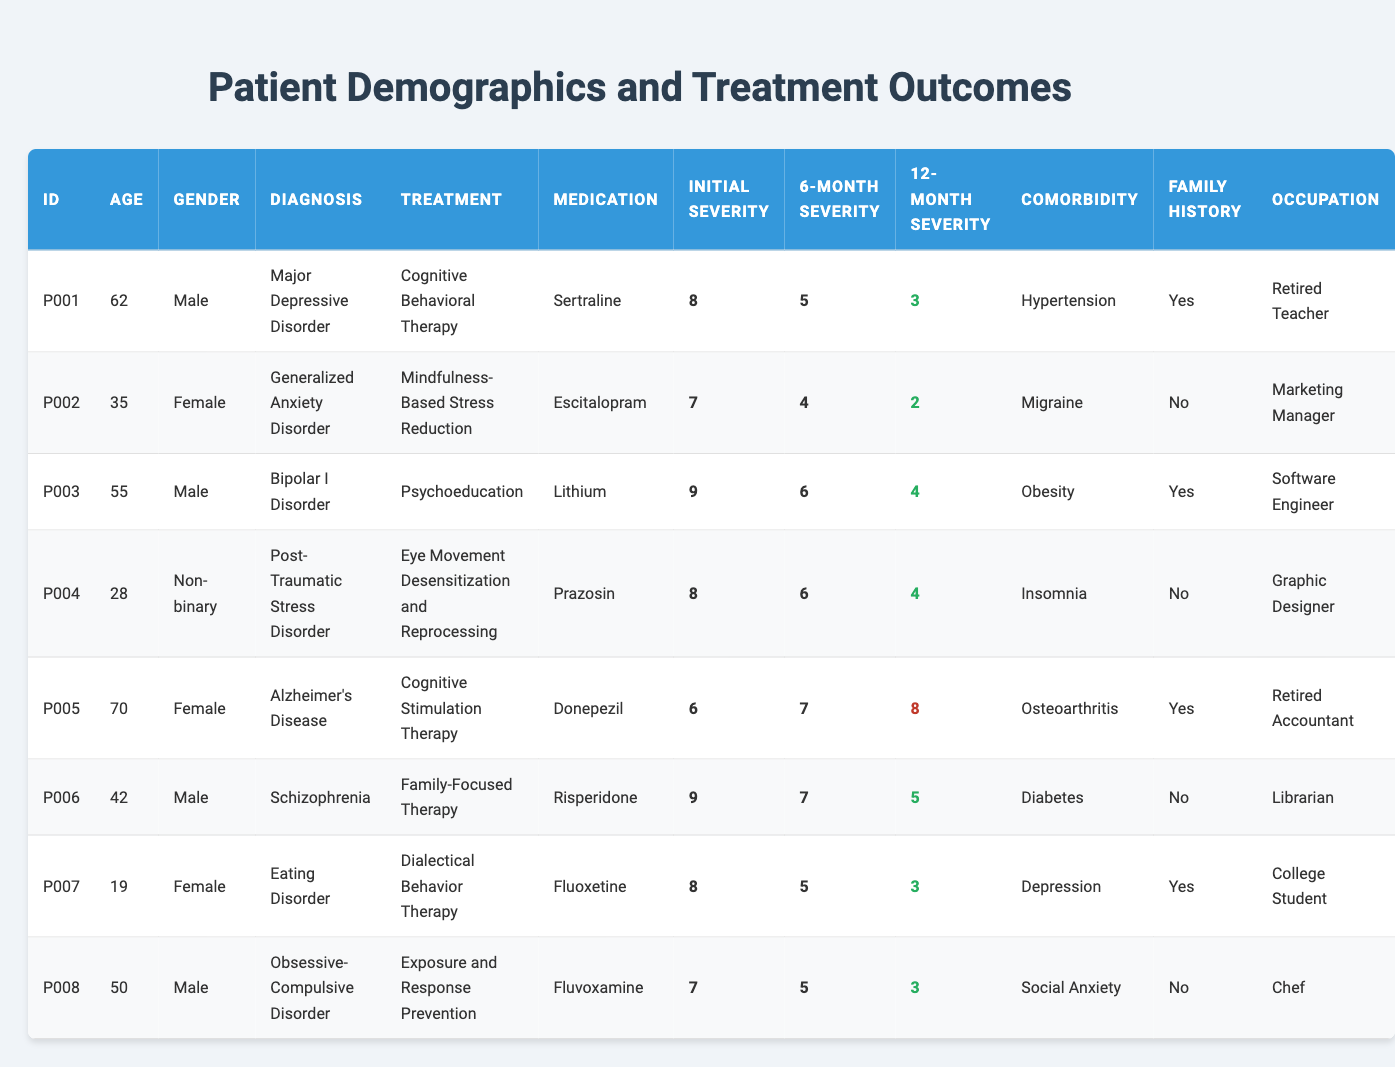What is the median age of the patients in the table? The ages of the patients are 62, 35, 55, 28, 70, 42, 19, and 50. Arranging them in ascending order: 19, 28, 35, 42, 50, 55, 62, 70. The median is the average of the two middle values (42 and 50), which is (42 + 50) / 2 = 46.
Answer: 46 Which patient had the highest initial severity score? The initial severity scores are 8, 7, 9, 8, 6, 9, 8, and 7. The highest score is 9. Upon checking, patients P003 and P006 both have an initial severity of 9.
Answer: P003 and P006 Did any patient experience an increase in severity from their initial to 12-month assessment? Comparing the initial severity to the 12-month severity: P001 (8 to 3), P002 (7 to 2), P003 (9 to 4), P004 (8 to 4), P005 (6 to 8), P006 (9 to 5), P007 (8 to 3), and P008 (7 to 3). Only P005 increased from 6 to 8.
Answer: Yes, P005 What percentage of patients had a family history of mental health disorders? There are 8 patients listed, and 5 of them have "Yes" marked under family history. To find the percentage, (5 / 8) * 100 = 62.5%.
Answer: 62.5% What treatment was used for the patient diagnosed with schizophrenia? The patient with the diagnosis of schizophrenia is P006, and he received Family-Focused Therapy as treatment.
Answer: Family-Focused Therapy What is the difference in 6-month severity scores between the youngest (P007) and the oldest patient (P005)? The 6-month severity score for P007 (19 years old) is 5 and for P005 (70 years old) is 7. The difference is 7 - 5 = 2.
Answer: 2 Which diagnosis had the lowest initial severity score, and what was that score? The initial severity scores are: Major Depressive Disorder 8, Generalized Anxiety Disorder 7, Bipolar I Disorder 9, Post-Traumatic Stress Disorder 8, Alzheimer's Disease 6, Schizophrenia 9, Eating Disorder 8, and Obsessive-Compulsive Disorder 7. The lowest score is 6 for Alzheimer's Disease.
Answer: Alzheimer’s Disease, 6 How many patients improved in severity after 12 months? Assessing the changes in severity after 12 months: P001 (8 to 3), P002 (7 to 2), P003 (9 to 4), P004 (8 to 4), P005 (6 to 8, worsened), P006 (9 to 5), P007 (8 to 3), P008 (7 to 3). 
Patients P001, P002, P003, P004, P007, and P008 improved, which totals to 6 patients.
Answer: 6 What was the most common medication listed among the patients? The medications listed are: Sertraline, Escitalopram, Lithium, Prazosin, Donepezil, Risperidone, Fluoxetine, and Fluvoxamine. There are no repetitions among the medications, so none is more common. Each is unique.
Answer: None (all medications are unique) What is the level of improvement in severity for P007? The initial severity for P007 was 8, the 6-month severity is 5, and the 12-month severity is 3. The reduction from initial (8) to 12-month (3) is 5.
Answer: 5 